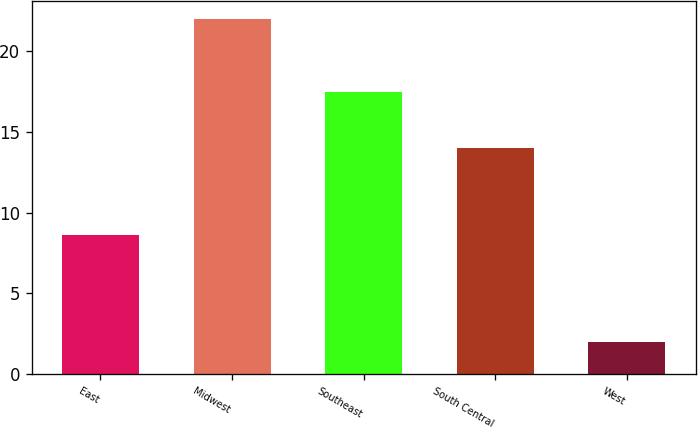Convert chart to OTSL. <chart><loc_0><loc_0><loc_500><loc_500><bar_chart><fcel>East<fcel>Midwest<fcel>Southeast<fcel>South Central<fcel>West<nl><fcel>8.6<fcel>22<fcel>17.5<fcel>14<fcel>2<nl></chart> 